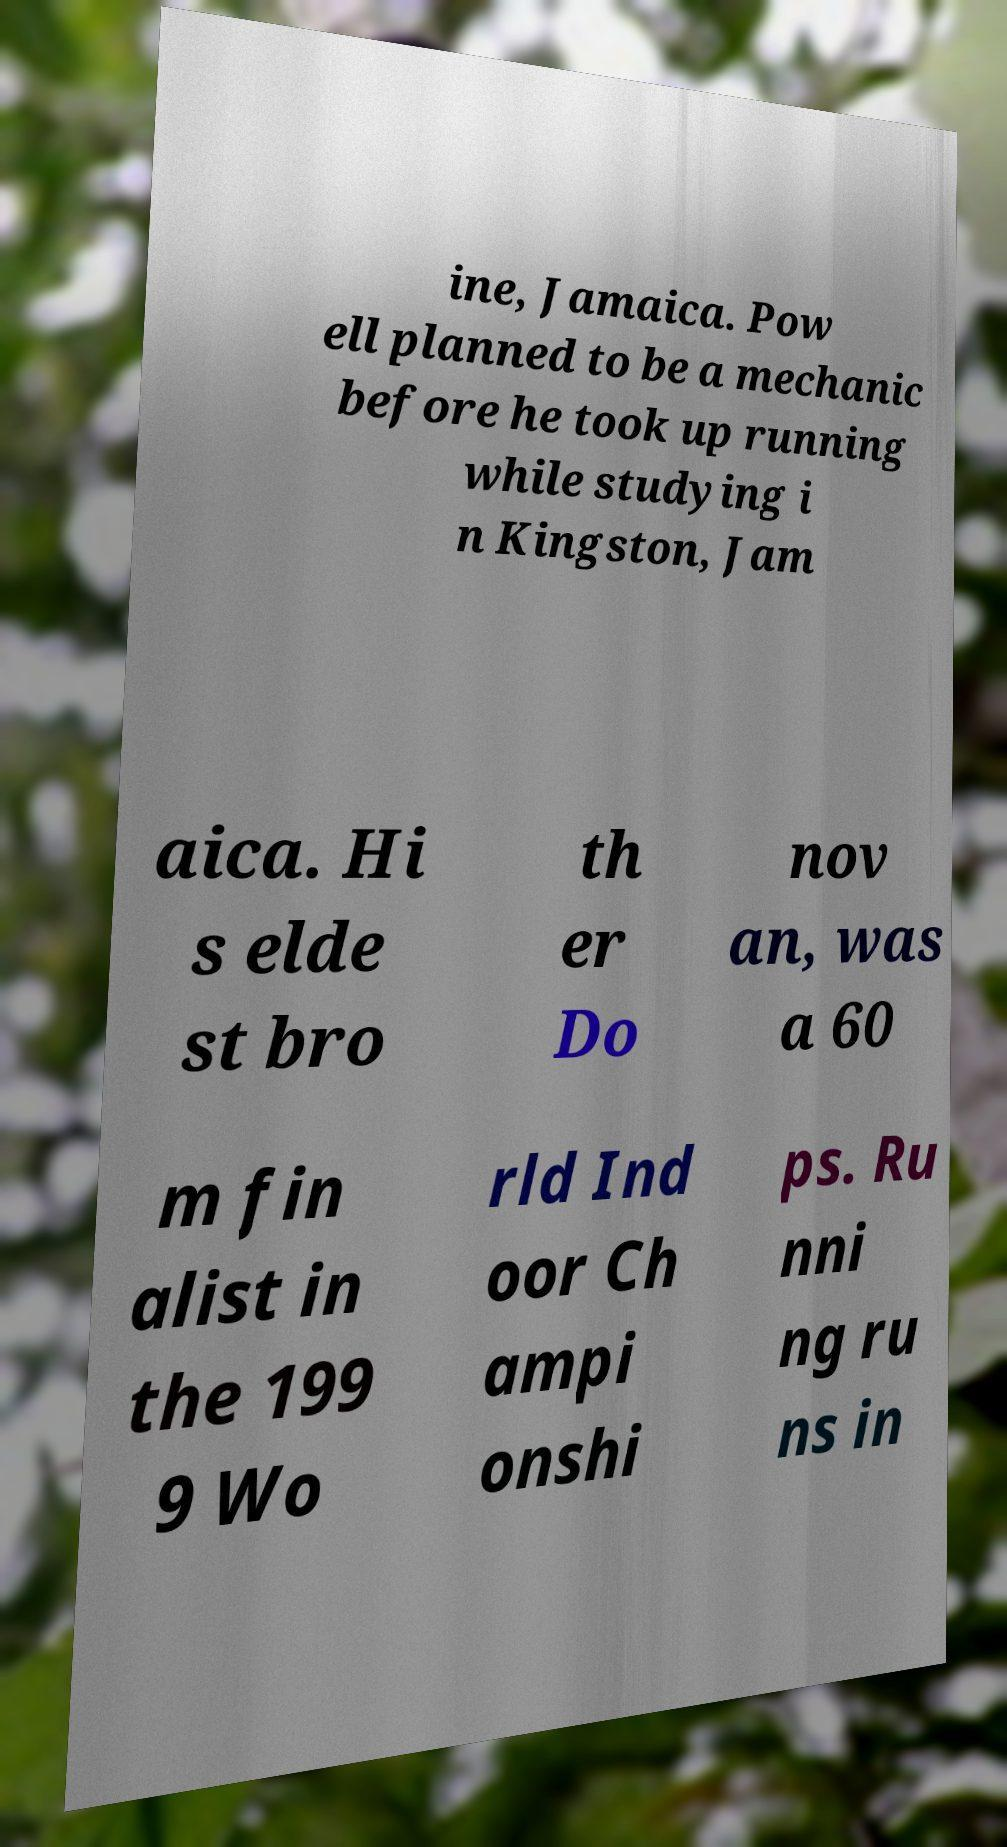Could you extract and type out the text from this image? ine, Jamaica. Pow ell planned to be a mechanic before he took up running while studying i n Kingston, Jam aica. Hi s elde st bro th er Do nov an, was a 60 m fin alist in the 199 9 Wo rld Ind oor Ch ampi onshi ps. Ru nni ng ru ns in 